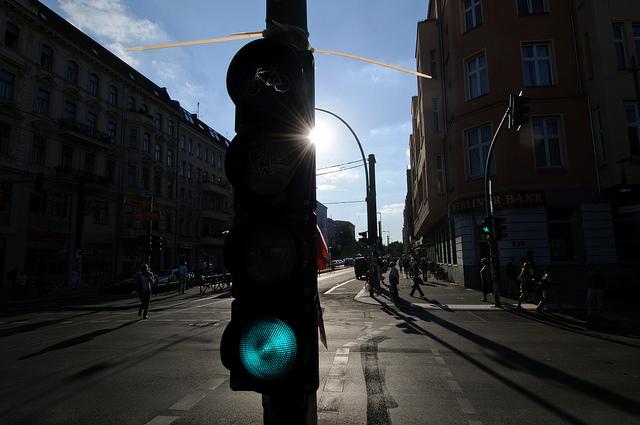Would a car stop at this stoplight?
Give a very brief answer. No. Is this a busy street?
Answer briefly. No. Is this an intersection?
Keep it brief. Yes. 